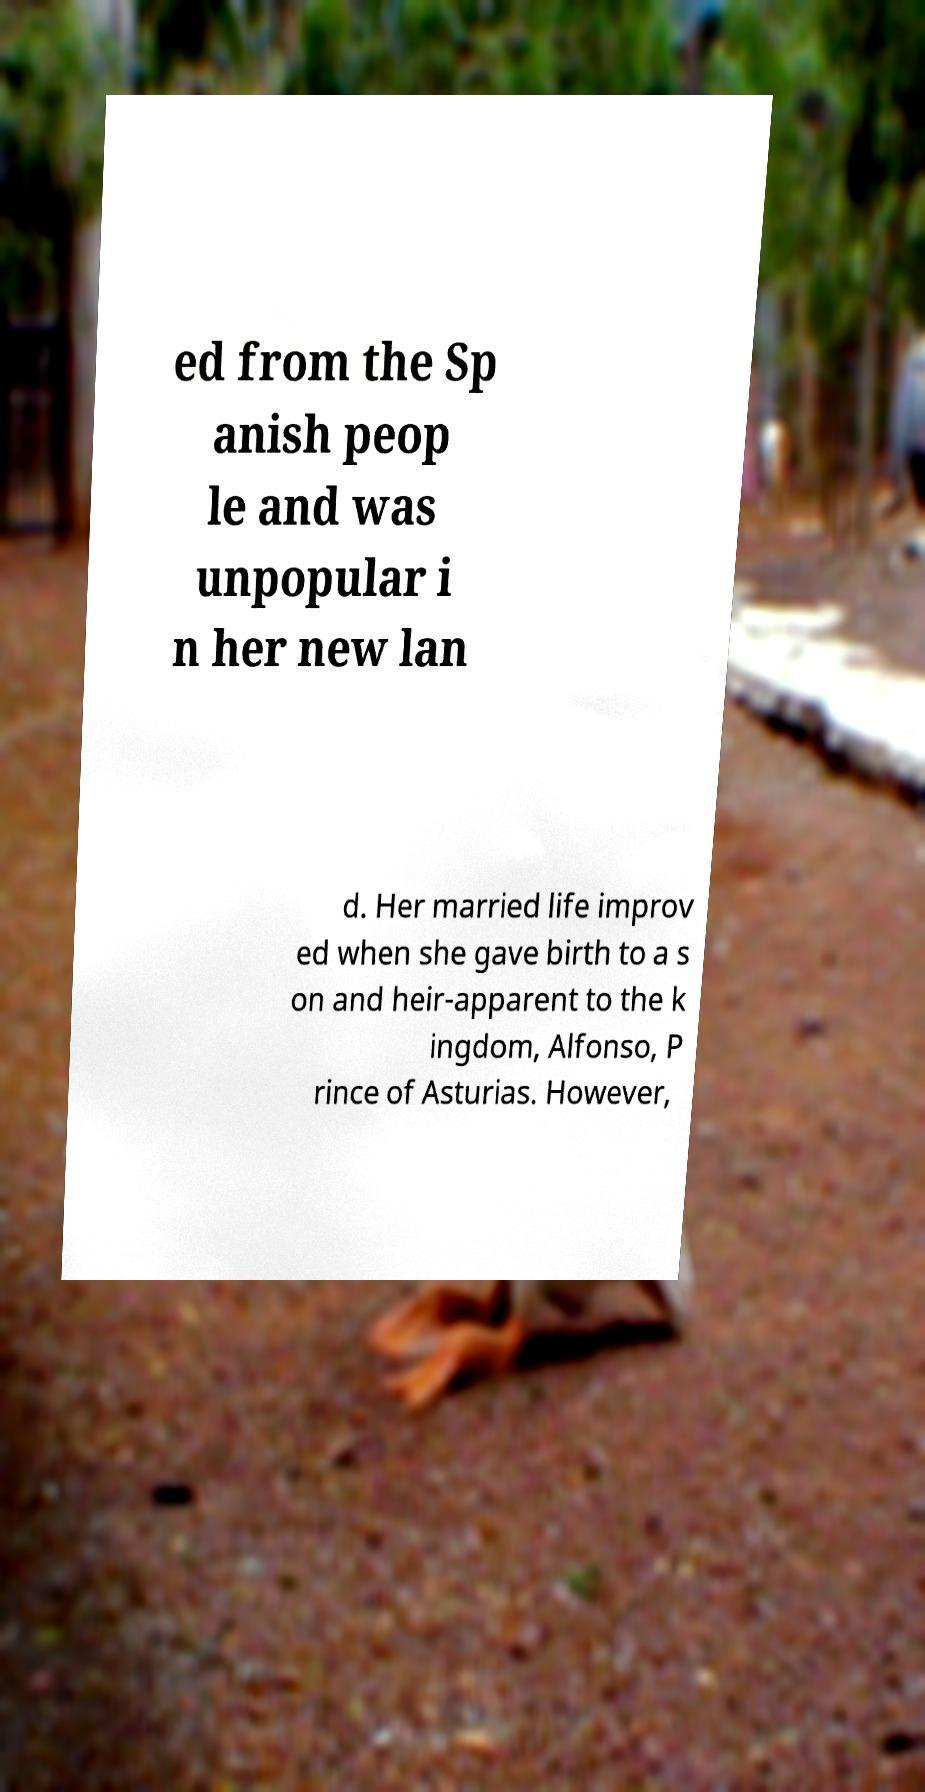There's text embedded in this image that I need extracted. Can you transcribe it verbatim? ed from the Sp anish peop le and was unpopular i n her new lan d. Her married life improv ed when she gave birth to a s on and heir-apparent to the k ingdom, Alfonso, P rince of Asturias. However, 